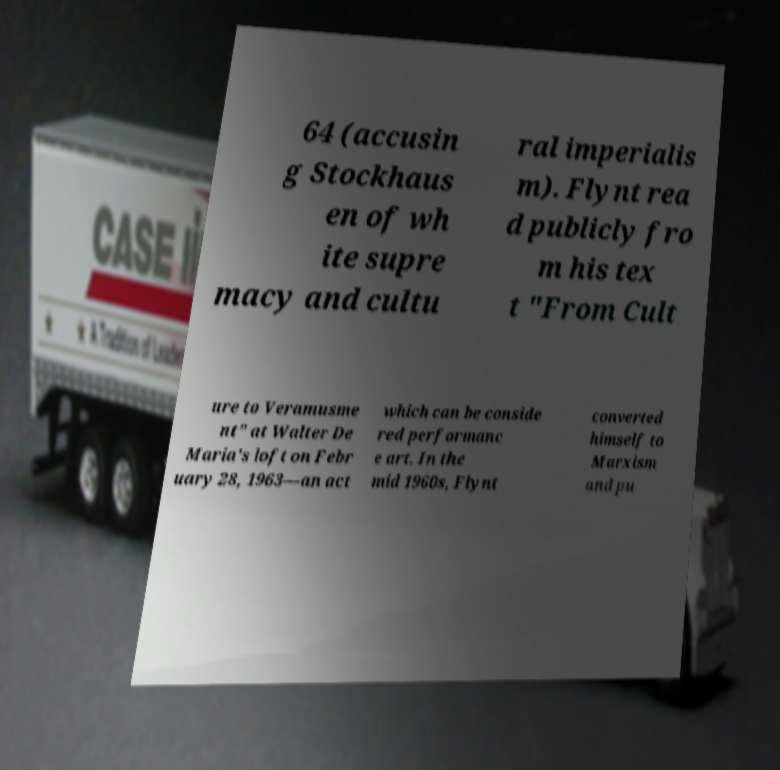Can you accurately transcribe the text from the provided image for me? 64 (accusin g Stockhaus en of wh ite supre macy and cultu ral imperialis m). Flynt rea d publicly fro m his tex t "From Cult ure to Veramusme nt" at Walter De Maria's loft on Febr uary 28, 1963—an act which can be conside red performanc e art. In the mid 1960s, Flynt converted himself to Marxism and pu 